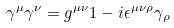<formula> <loc_0><loc_0><loc_500><loc_500>\gamma ^ { \mu } \gamma ^ { \nu } = g ^ { \mu \nu } 1 - i \epsilon ^ { \mu \nu \rho } \gamma _ { \rho }</formula> 